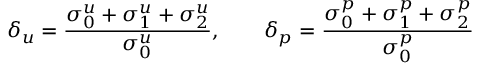<formula> <loc_0><loc_0><loc_500><loc_500>\delta _ { u } = \frac { \sigma _ { 0 } ^ { u } + \sigma _ { 1 } ^ { u } + \sigma _ { 2 } ^ { u } } { \sigma _ { 0 } ^ { u } } , \quad \delta _ { p } = \frac { \sigma _ { 0 } ^ { p } + \sigma _ { 1 } ^ { p } + \sigma _ { 2 } ^ { p } } { \sigma _ { 0 } ^ { p } }</formula> 